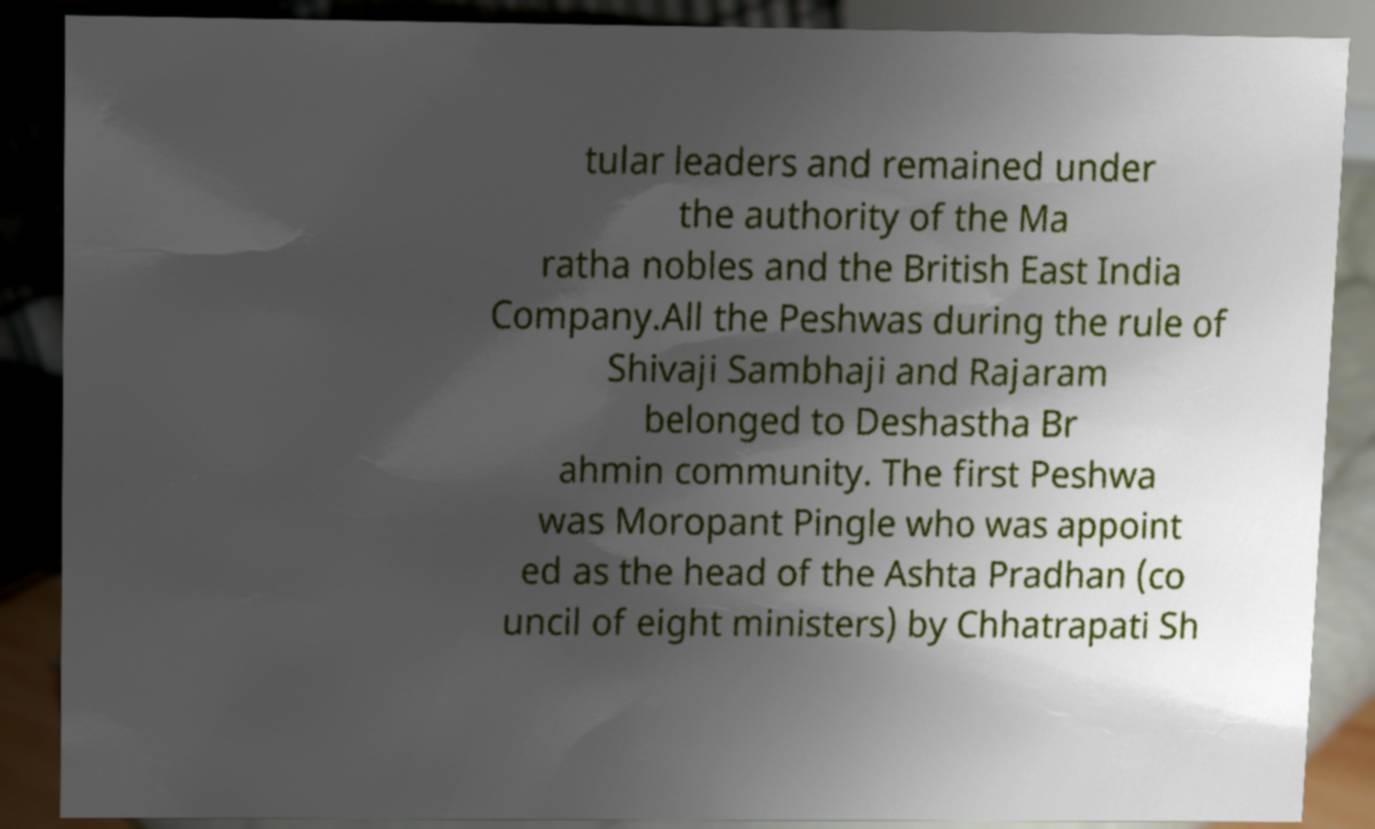I need the written content from this picture converted into text. Can you do that? tular leaders and remained under the authority of the Ma ratha nobles and the British East India Company.All the Peshwas during the rule of Shivaji Sambhaji and Rajaram belonged to Deshastha Br ahmin community. The first Peshwa was Moropant Pingle who was appoint ed as the head of the Ashta Pradhan (co uncil of eight ministers) by Chhatrapati Sh 